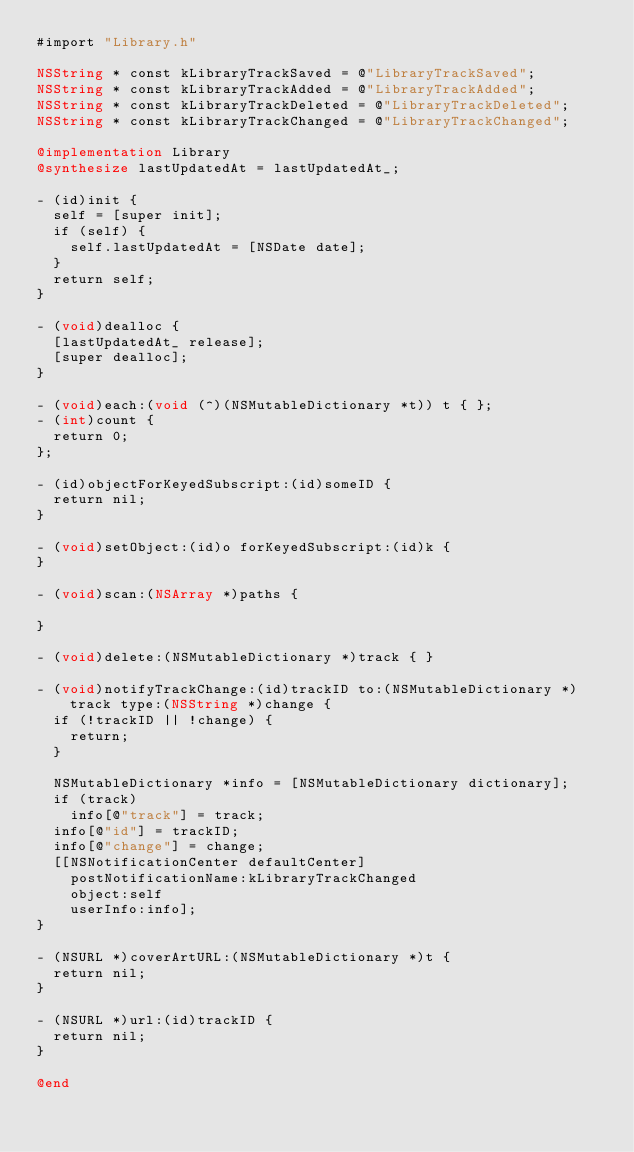Convert code to text. <code><loc_0><loc_0><loc_500><loc_500><_ObjectiveC_>#import "Library.h"

NSString * const kLibraryTrackSaved = @"LibraryTrackSaved";
NSString * const kLibraryTrackAdded = @"LibraryTrackAdded";
NSString * const kLibraryTrackDeleted = @"LibraryTrackDeleted";
NSString * const kLibraryTrackChanged = @"LibraryTrackChanged";

@implementation Library
@synthesize lastUpdatedAt = lastUpdatedAt_;

- (id)init {
  self = [super init];
  if (self) {
    self.lastUpdatedAt = [NSDate date];
  }
  return self;
}

- (void)dealloc {
  [lastUpdatedAt_ release];
  [super dealloc];
}

- (void)each:(void (^)(NSMutableDictionary *t)) t { };
- (int)count {
  return 0;
};

- (id)objectForKeyedSubscript:(id)someID {
  return nil;
}

- (void)setObject:(id)o forKeyedSubscript:(id)k {
}

- (void)scan:(NSArray *)paths {

}

- (void)delete:(NSMutableDictionary *)track { }

- (void)notifyTrackChange:(id)trackID to:(NSMutableDictionary *)track type:(NSString *)change {
  if (!trackID || !change) {
    return;
  }

  NSMutableDictionary *info = [NSMutableDictionary dictionary];
  if (track)
    info[@"track"] = track;
  info[@"id"] = trackID;
  info[@"change"] = change;
  [[NSNotificationCenter defaultCenter]
    postNotificationName:kLibraryTrackChanged
    object:self
    userInfo:info];
}

- (NSURL *)coverArtURL:(NSMutableDictionary *)t {
  return nil;
}

- (NSURL *)url:(id)trackID {
  return nil;
}

@end

</code> 